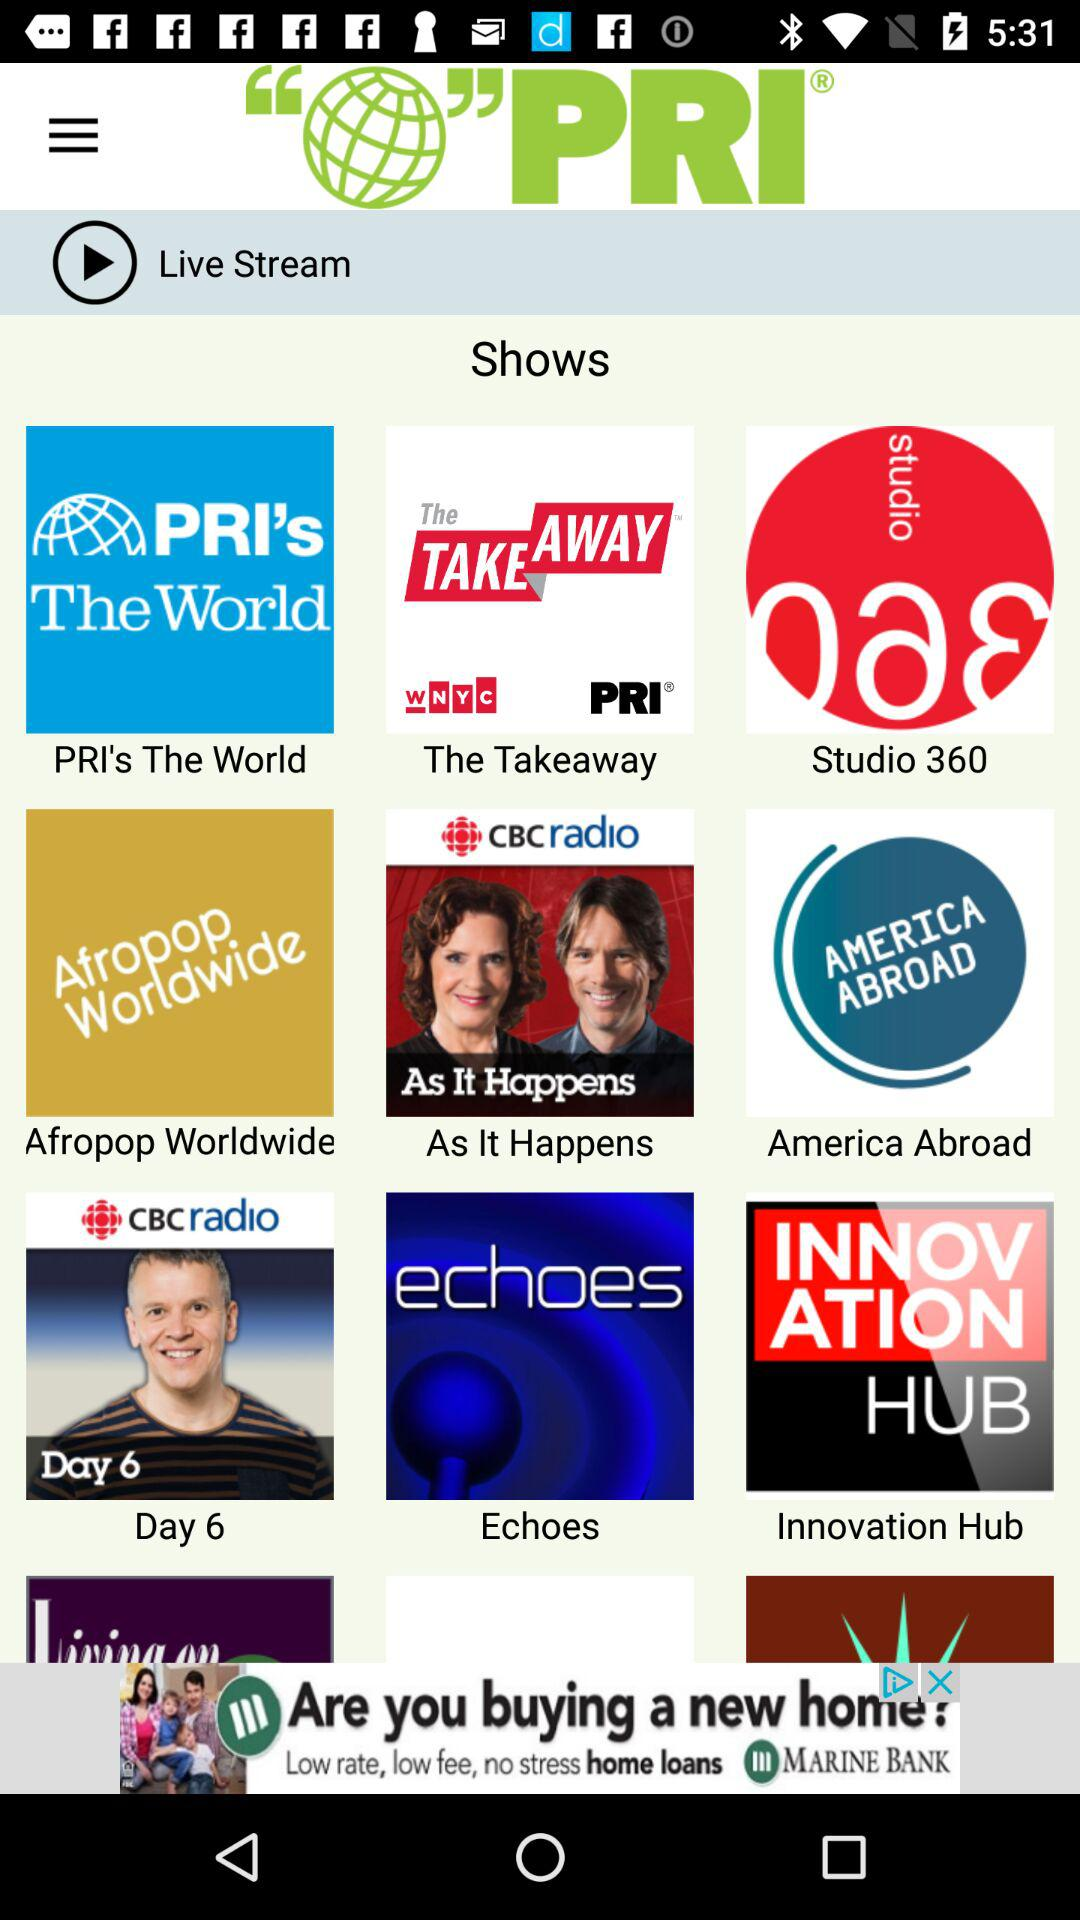What are the names of the shows? The names are "PRI's The World", "The Takeaway", "Studio 360", "Afropop Worldwide", "As It Happens", "America Abroad", "Day 6", "Echoes" and "Innovation Hub". 